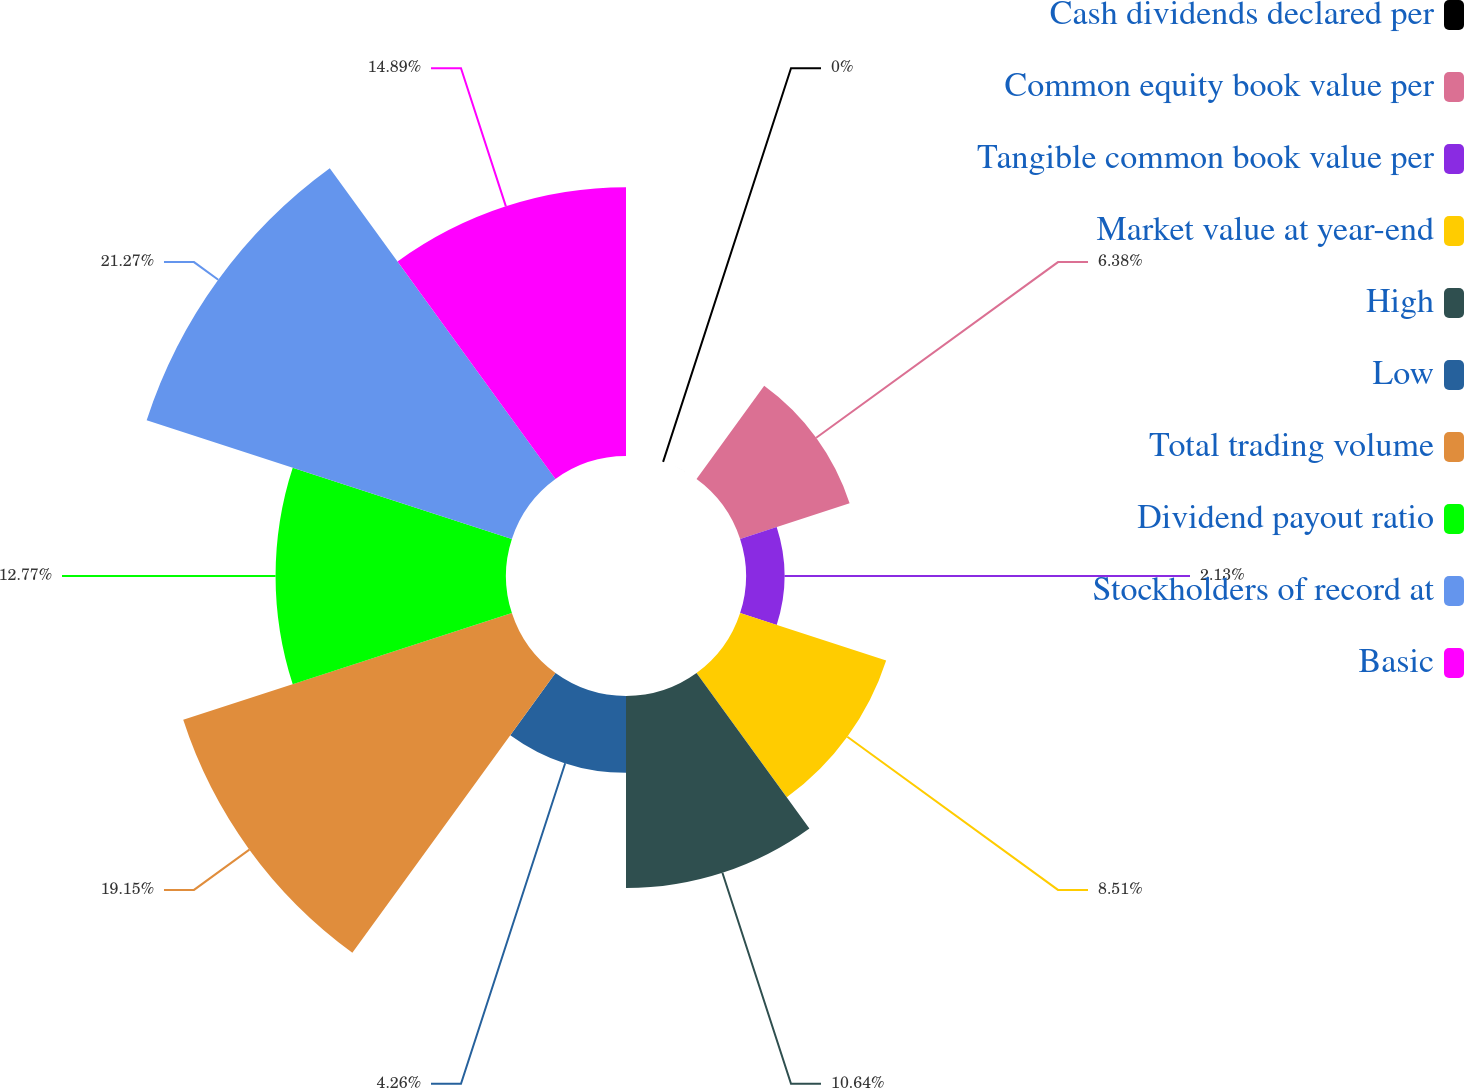Convert chart to OTSL. <chart><loc_0><loc_0><loc_500><loc_500><pie_chart><fcel>Cash dividends declared per<fcel>Common equity book value per<fcel>Tangible common book value per<fcel>Market value at year-end<fcel>High<fcel>Low<fcel>Total trading volume<fcel>Dividend payout ratio<fcel>Stockholders of record at<fcel>Basic<nl><fcel>0.0%<fcel>6.38%<fcel>2.13%<fcel>8.51%<fcel>10.64%<fcel>4.26%<fcel>19.15%<fcel>12.77%<fcel>21.28%<fcel>14.89%<nl></chart> 